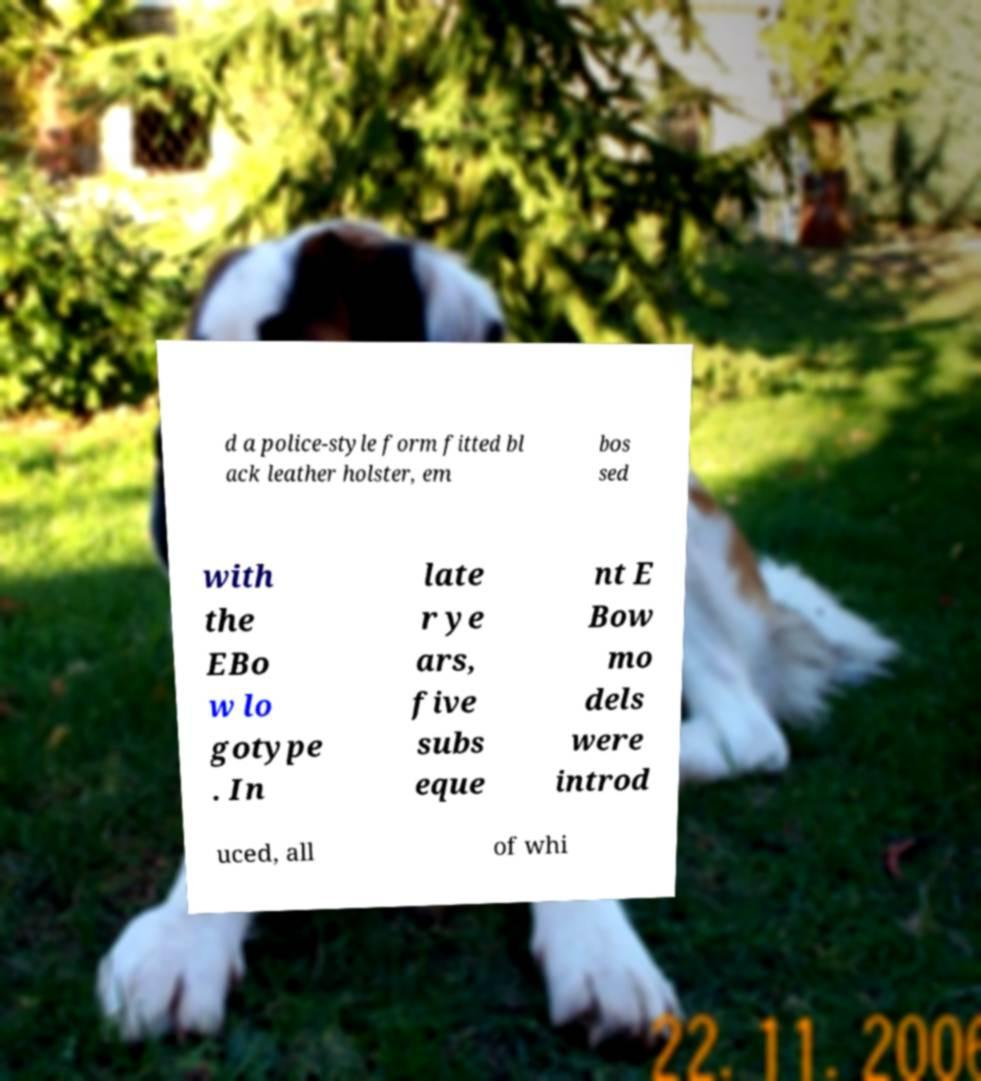Can you read and provide the text displayed in the image?This photo seems to have some interesting text. Can you extract and type it out for me? d a police-style form fitted bl ack leather holster, em bos sed with the EBo w lo gotype . In late r ye ars, five subs eque nt E Bow mo dels were introd uced, all of whi 